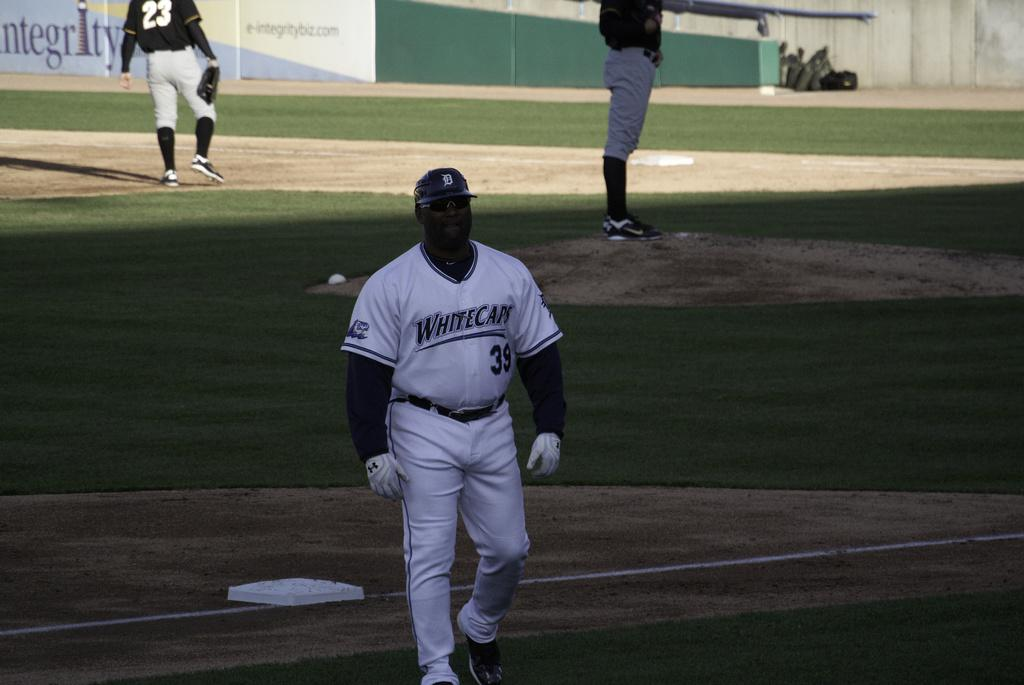<image>
Relay a brief, clear account of the picture shown. A man wearing a Whitecaps uniform is walking off a baseball field. 